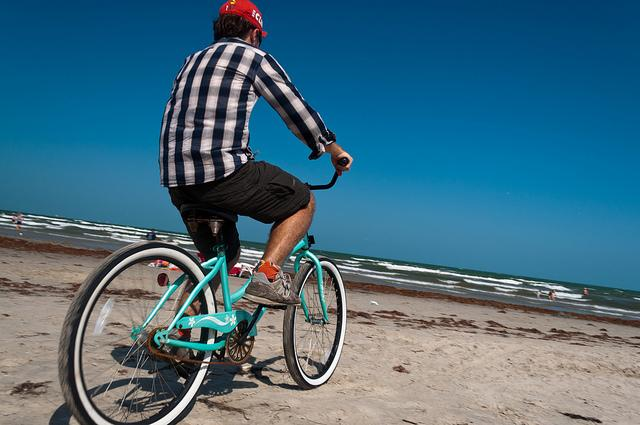What will happen to this mans feet if he doesn't stop? get wet 